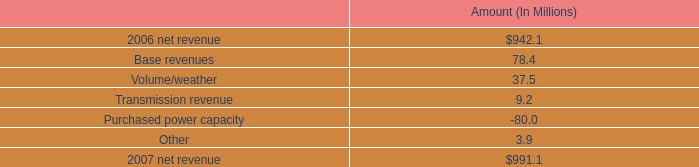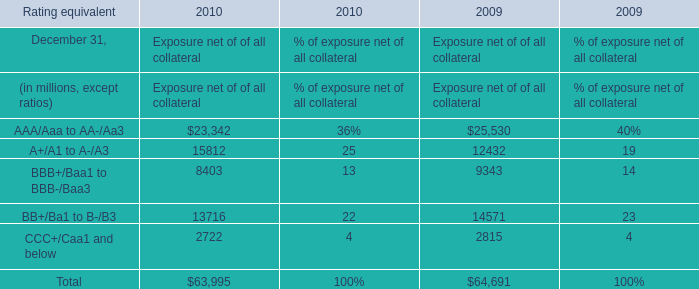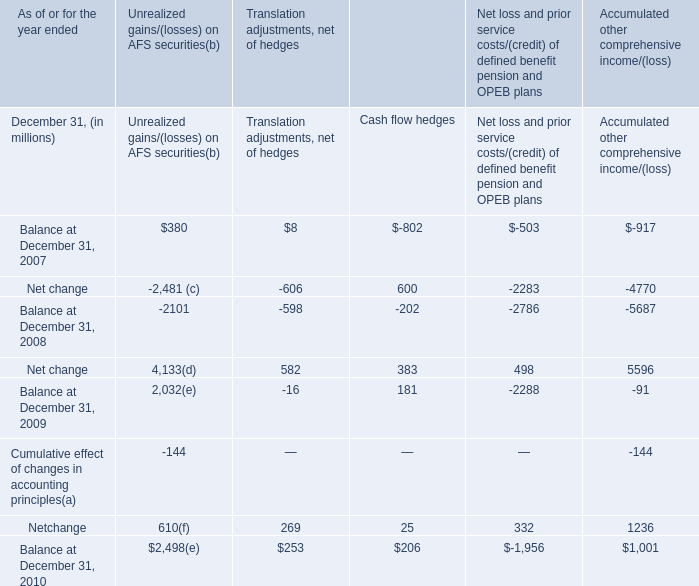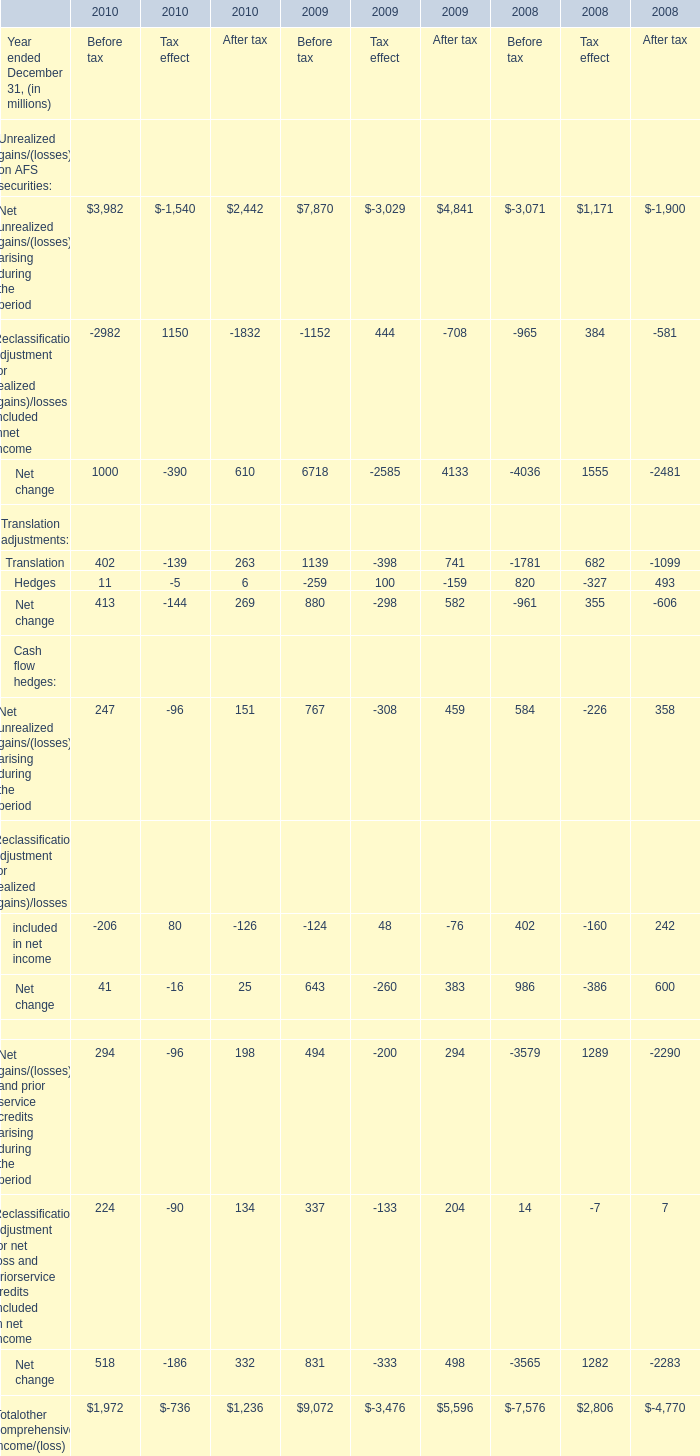Does Unrealized gains/(losses) on AFS securities of Net change for After tax keeps increasing each year between 2009 and 2010? 
Answer: no. 